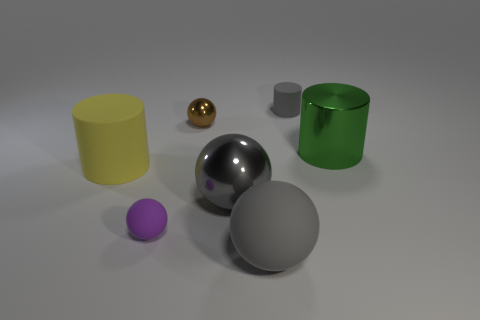Add 2 small cyan matte spheres. How many objects exist? 9 Subtract all spheres. How many objects are left? 3 Add 3 gray cylinders. How many gray cylinders exist? 4 Subtract 0 yellow cubes. How many objects are left? 7 Subtract all cylinders. Subtract all large matte cylinders. How many objects are left? 3 Add 7 big green shiny cylinders. How many big green shiny cylinders are left? 8 